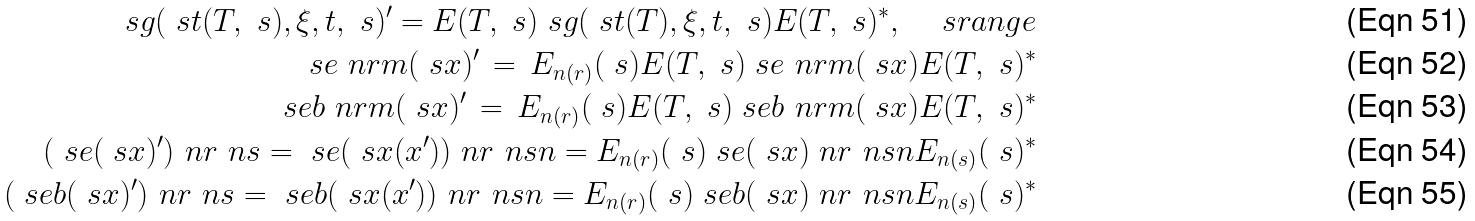Convert formula to latex. <formula><loc_0><loc_0><loc_500><loc_500>\ s g ( \ s t ( T , \ s ) , \xi , t , \ s ) ^ { \prime } = E ( T , \ s ) \ s g ( \ s t ( T ) , \xi , t , \ s ) E ( T , \ s ) ^ { \ast } , \quad \ s r a n g e \\ \ s e _ { \ } n r m ( \ s x ) ^ { \prime } \, = \, E _ { n ( r ) } ( \ s ) E ( T , \ s ) \ s e _ { \ } n r m ( \ s x ) E ( T , \ s ) ^ { \ast } \\ \ s e b _ { \ } n r m ( \ s x ) ^ { \prime } \, = \, E _ { n ( r ) } ( \ s ) E ( T , \ s ) \ s e b _ { \ } n r m ( \ s x ) E ( T , \ s ) ^ { \ast } \\ ( \ s e ( \ s x ) ^ { \prime } ) _ { \ } n r ^ { \ } n s = \ s e ( \ s x ( x ^ { \prime } ) ) _ { \ } n r ^ { \ } n s n = E _ { n ( r ) } ( \ s ) \ s e ( \ s x ) _ { \ } n r ^ { \ } n s n E _ { n ( s ) } ( \ s ) ^ { \ast } \\ ( \ s e b ( \ s x ) ^ { \prime } ) _ { \ } n r ^ { \ } n s = \ s e b ( \ s x ( x ^ { \prime } ) ) _ { \ } n r ^ { \ } n s n = E _ { n ( r ) } ( \ s ) \ s e b ( \ s x ) _ { \ } n r ^ { \ } n s n E _ { n ( s ) } ( \ s ) ^ { \ast }</formula> 